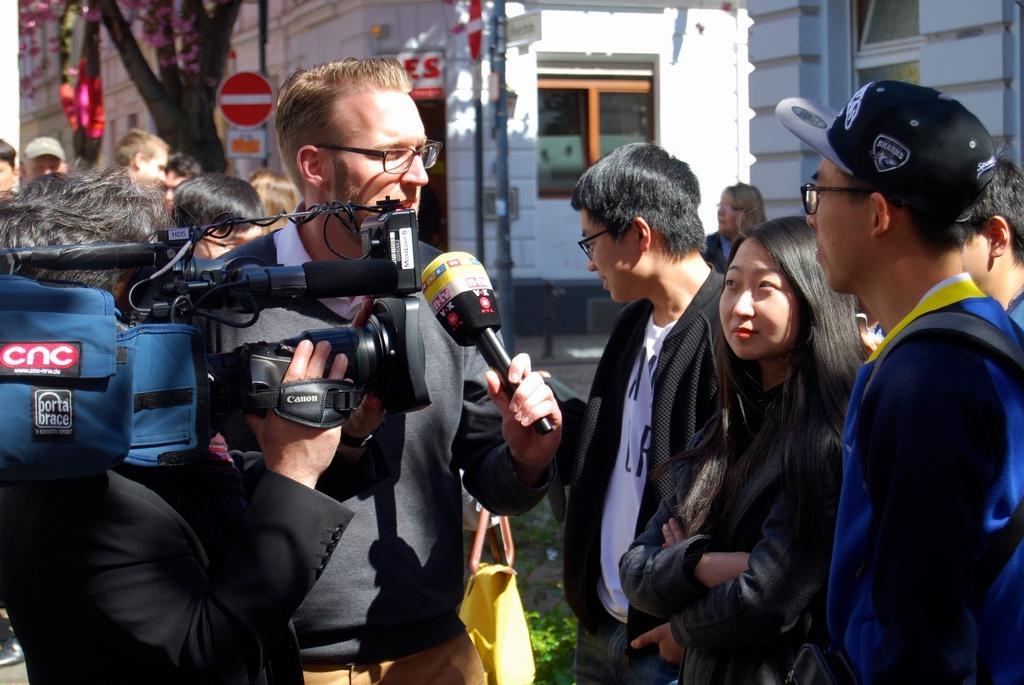Could you give a brief overview of what you see in this image? There is a group of persons standing on the right side of this image and there are some persons standing on the left side of this image. There person standing on the left side is holding a camera and the right side person is holding a Mic. There are some building and some trees in the background. 